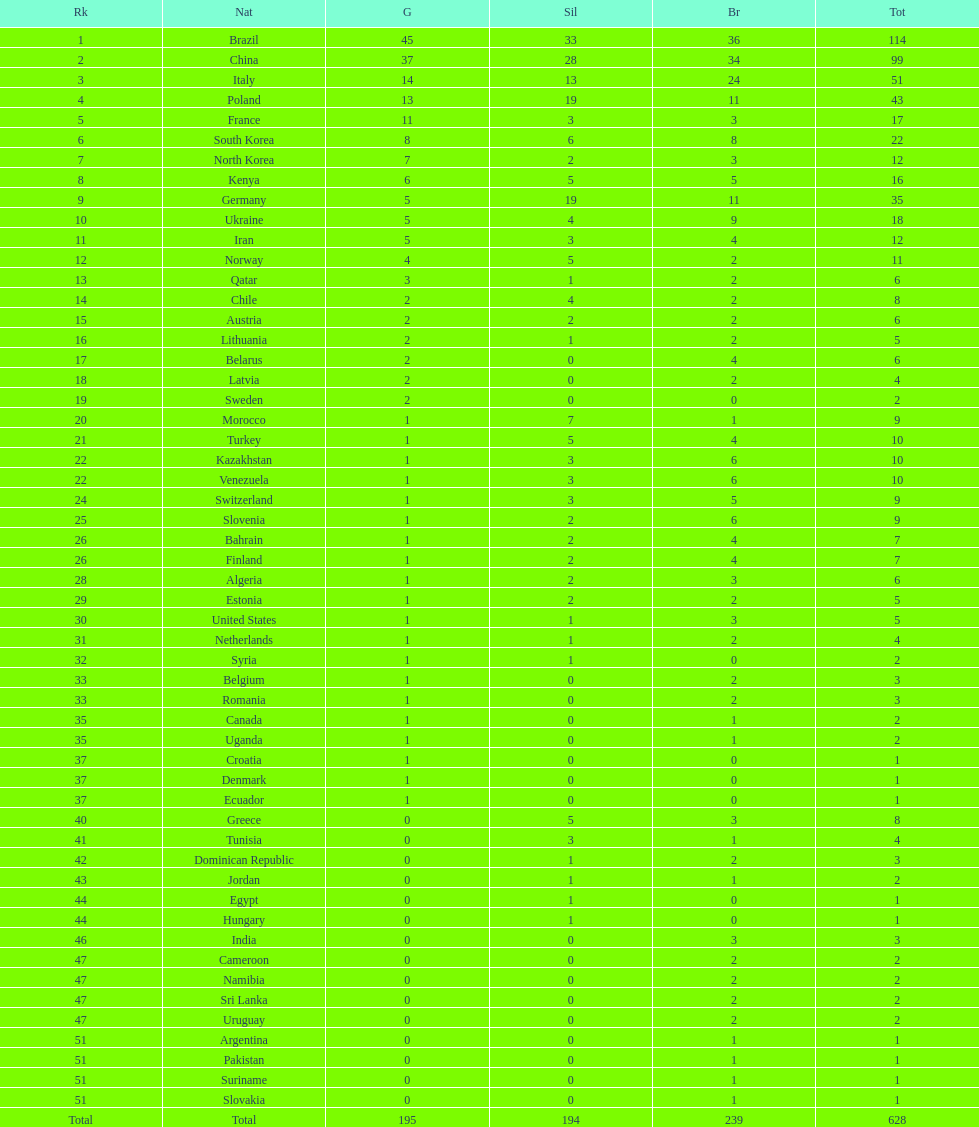What category of medal does belarus not possess? Silver. 